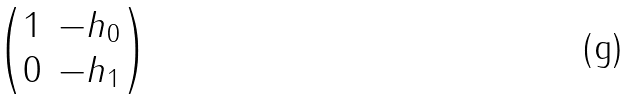<formula> <loc_0><loc_0><loc_500><loc_500>\begin{pmatrix} 1 & - h _ { 0 } \\ 0 & - h _ { 1 } \end{pmatrix}</formula> 